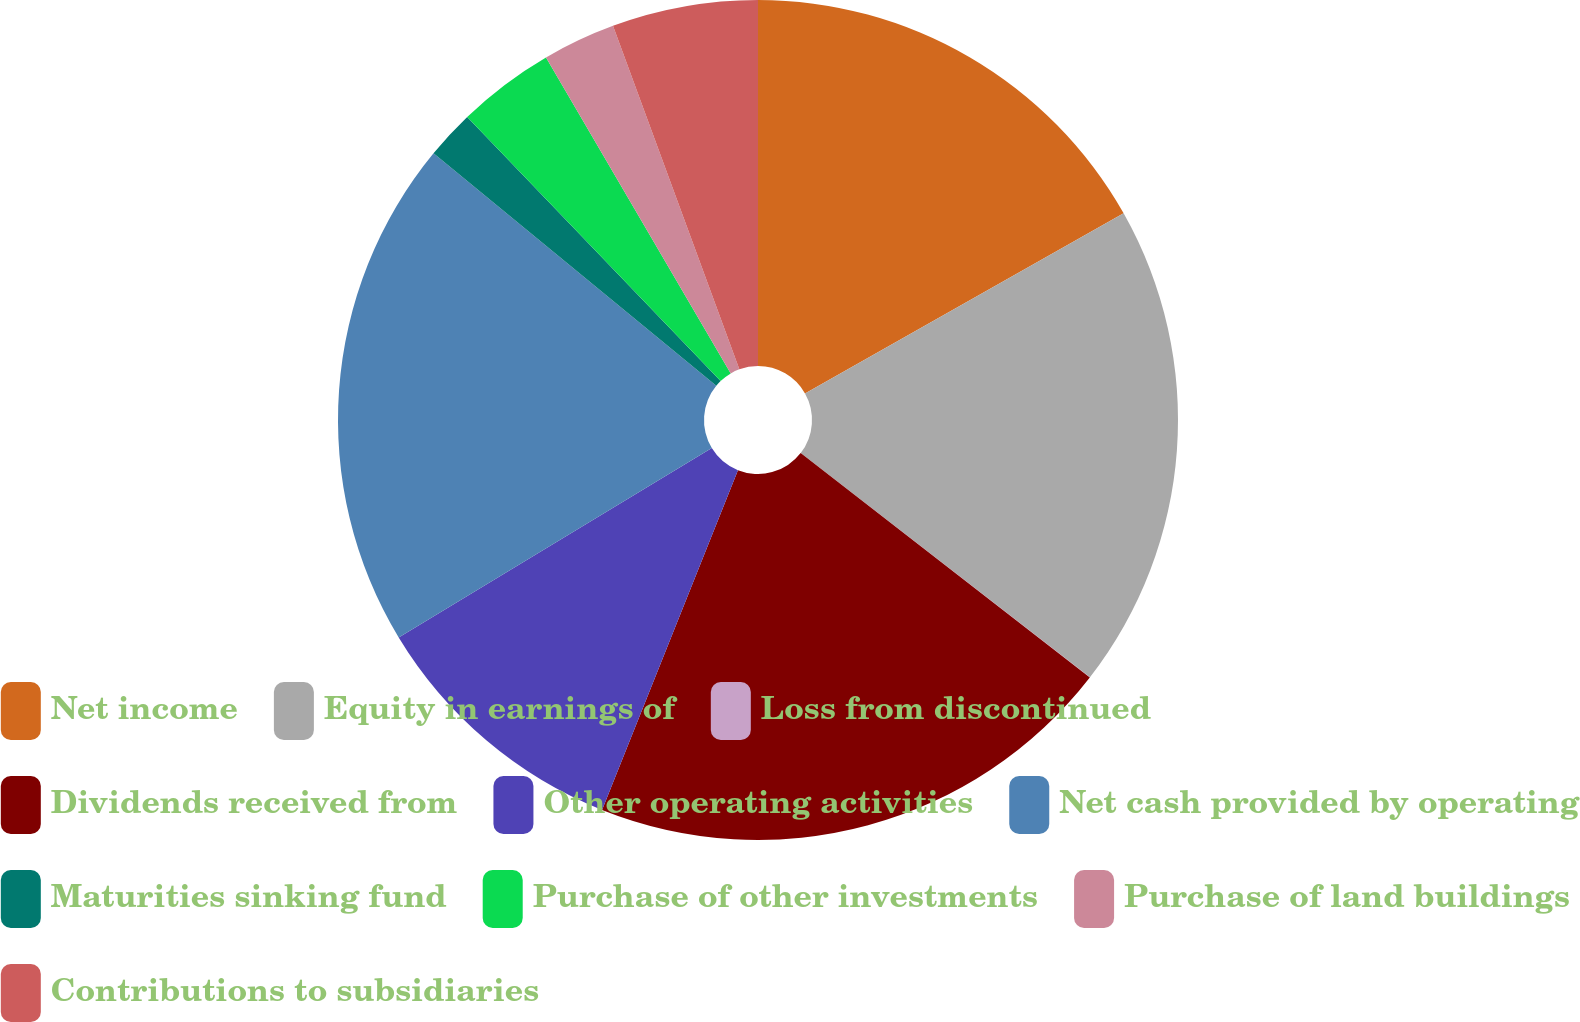<chart> <loc_0><loc_0><loc_500><loc_500><pie_chart><fcel>Net income<fcel>Equity in earnings of<fcel>Loss from discontinued<fcel>Dividends received from<fcel>Other operating activities<fcel>Net cash provided by operating<fcel>Maturities sinking fund<fcel>Purchase of other investments<fcel>Purchase of land buildings<fcel>Contributions to subsidiaries<nl><fcel>16.81%<fcel>18.68%<fcel>0.01%<fcel>20.55%<fcel>10.28%<fcel>19.61%<fcel>1.88%<fcel>3.75%<fcel>2.81%<fcel>5.61%<nl></chart> 